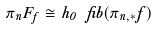<formula> <loc_0><loc_0><loc_500><loc_500>\pi _ { n } F _ { f } \cong h _ { 0 } \ f i b ( \pi _ { n , * } f )</formula> 